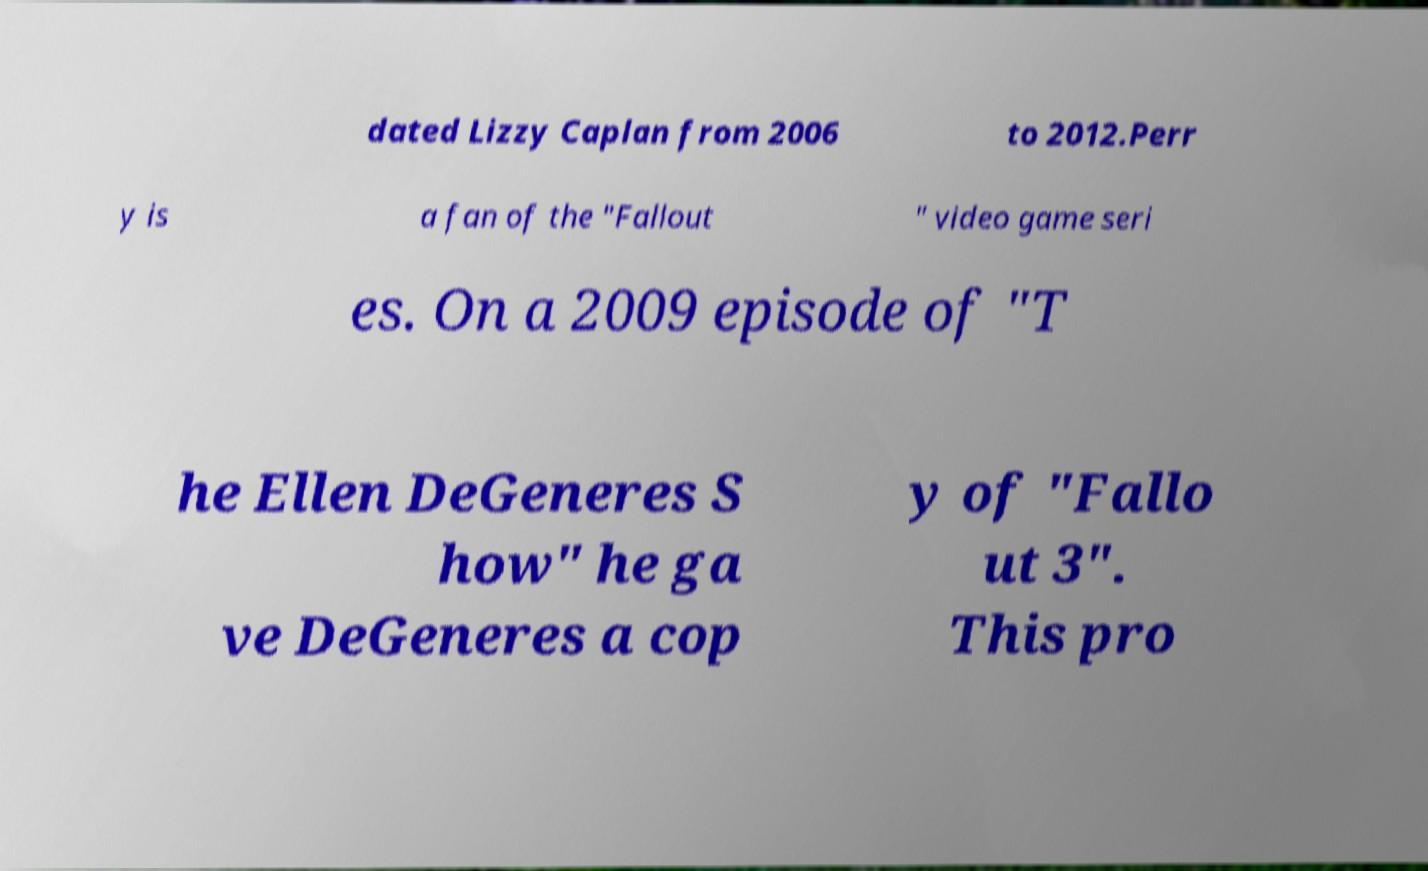Could you assist in decoding the text presented in this image and type it out clearly? dated Lizzy Caplan from 2006 to 2012.Perr y is a fan of the "Fallout " video game seri es. On a 2009 episode of "T he Ellen DeGeneres S how" he ga ve DeGeneres a cop y of "Fallo ut 3". This pro 